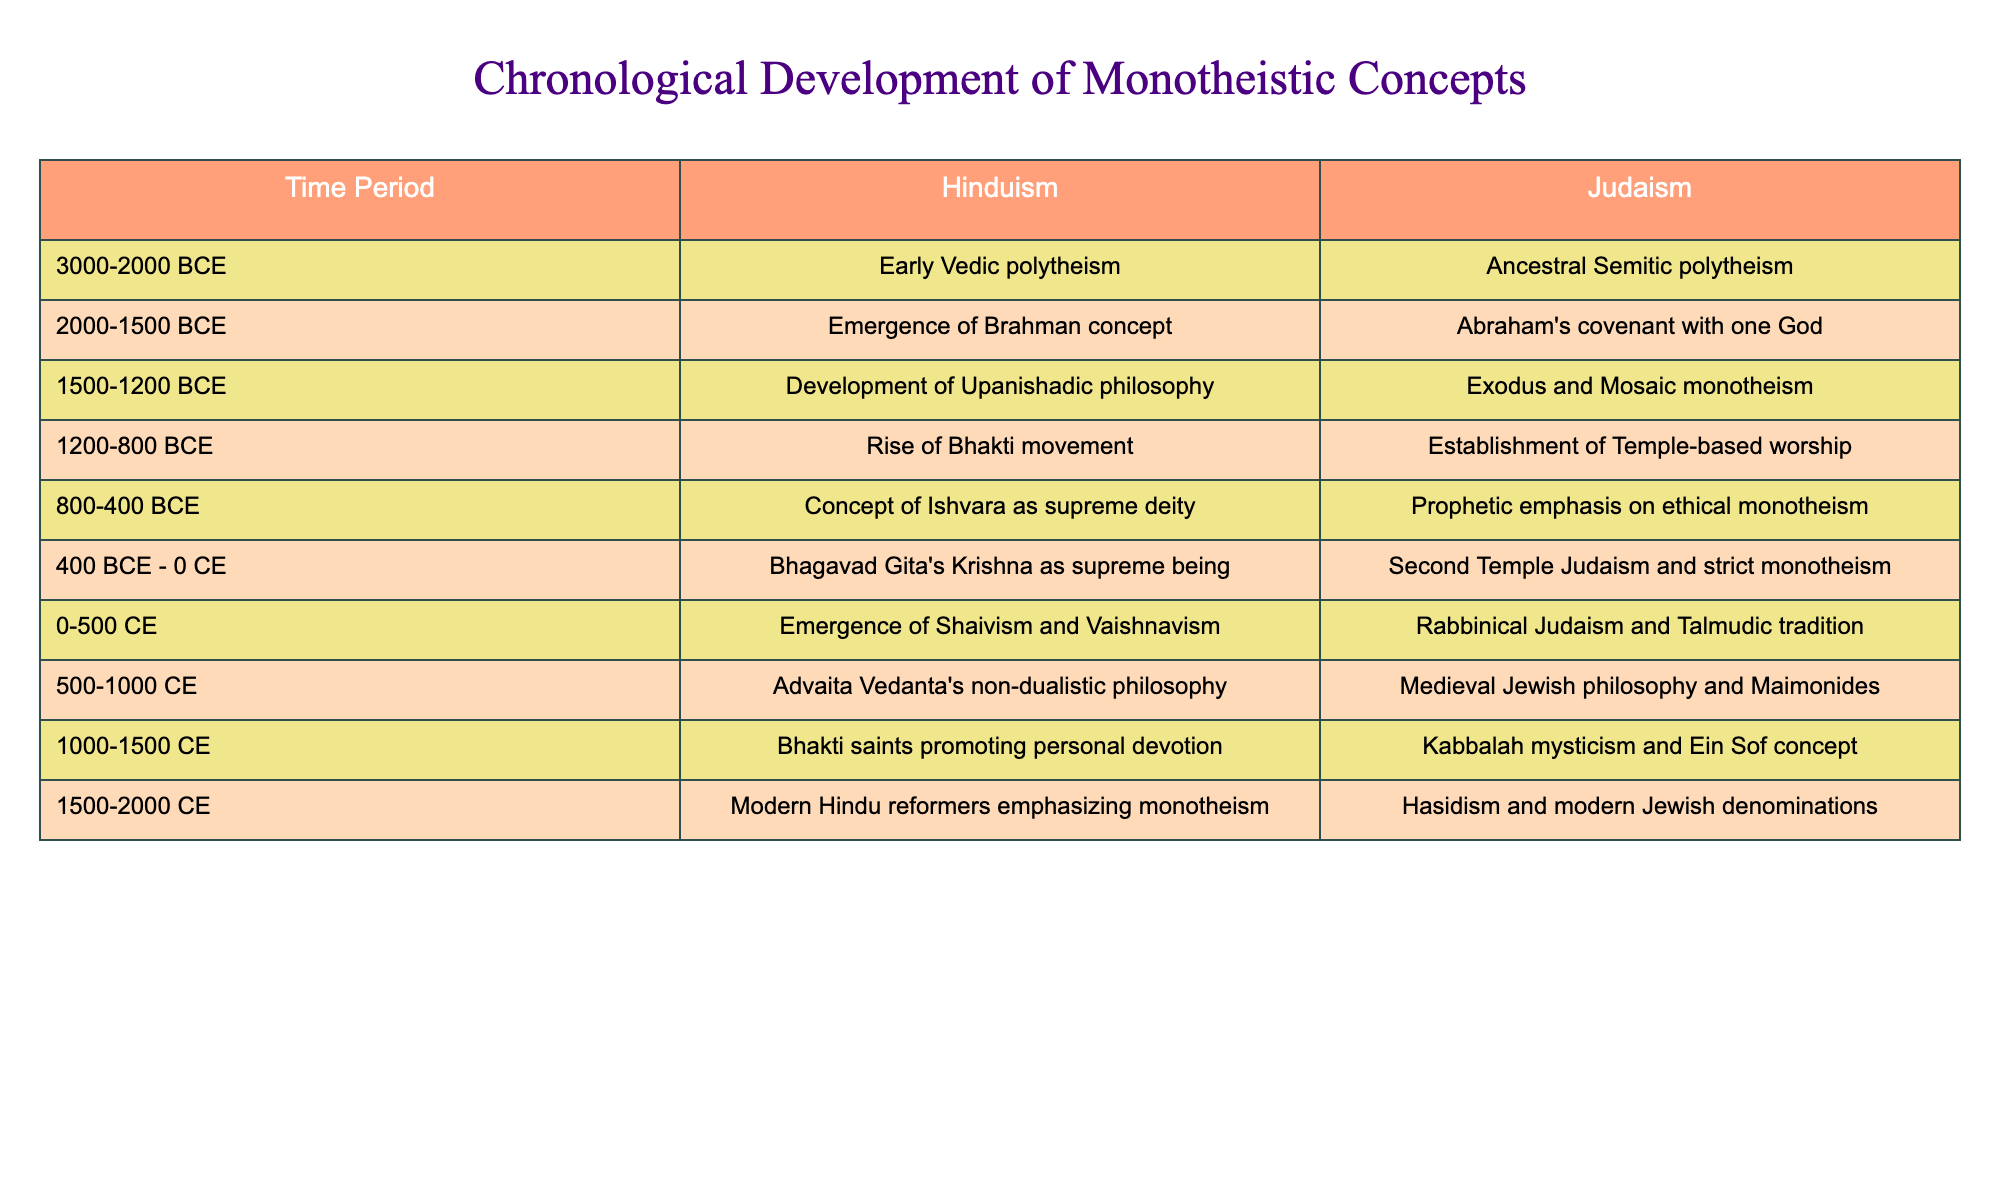What is the time period during which the concept of Ishvara as the supreme deity emerged in Hinduism? The table indicates that the concept of Ishvara as the supreme deity emerged between 800 and 400 BCE.
Answer: 800-400 BCE What monotheistic development occurred in Judaism around 1500-1200 BCE? According to the table, the significant development in Judaism during this period was the Exodus and Mosaic monotheism.
Answer: Exodus and Mosaic monotheism Which Hinduism philosophy was prominent from 500 to 1000 CE? The table shows that Advaita Vedanta's non-dualistic philosophy was prominent during this time.
Answer: Advaita Vedanta's non-dualistic philosophy Was the Bhakti movement significant in both Hinduism and Judaism? Yes, the Bhakti movement is noted in Hinduism, while Temple-based worship developed in Judaism, suggesting a form of personal devotion was significant in both traditions.
Answer: Yes How many distinct development phases can be identified for Judaism in the table? Counting the rows in the Judaism column of the table, there are eight distinct phases marked from 3000 BCE to 2000 CE.
Answer: Eight What is the difference in time periods between the emergence of Brahman concept in Hinduism and the establishment of Temple-based worship in Judaism? The Brahman concept emerged between 2000-1500 BCE, and the Temple-based worship was established between 1200-800 BCE, which results in a difference of approximately 400 years.
Answer: 400 years Which tradition introduced a strict form of monotheism first, Hinduism or Judaism? The table indicates that Judaism established strict monotheism around 400 BCE - 0 CE, whereas the concept of Krishna as a supreme being in Hinduism appeared in the same period, suggesting that Judaism introduced strict monotheism first.
Answer: Judaism Between which periods did Kabbalah mysticism develop in Judaism? Kabbalah mysticism developed during 1000-1500 CE based on the summarization of the table.
Answer: 1000-1500 CE What themes are seen in the last two developments in both religions? The last two developments for Hinduism emphasize personal devotion and reform, while for Judaism, there is a focus on modern denominations and Hasidism, showcasing a trend towards personal spirituality in both.
Answer: Personal spirituality Did the period 0-500 CE see significant developments in both religions? Yes, the table shows that both Hinduism had the emergence of Shaivism and Vaishnavism, and Judaism saw the rise of Rabbinical Judaism during this period.
Answer: Yes 